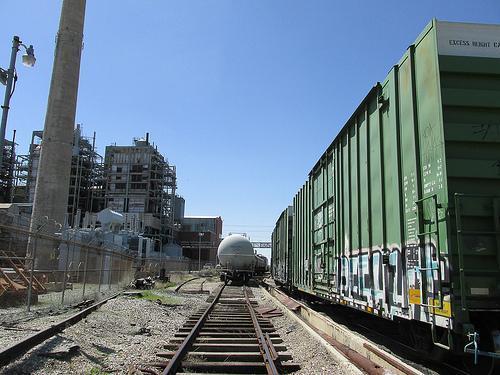How many train tracks are in the picture?
Give a very brief answer. 2. How many smokestacks are in the picture?
Give a very brief answer. 1. 